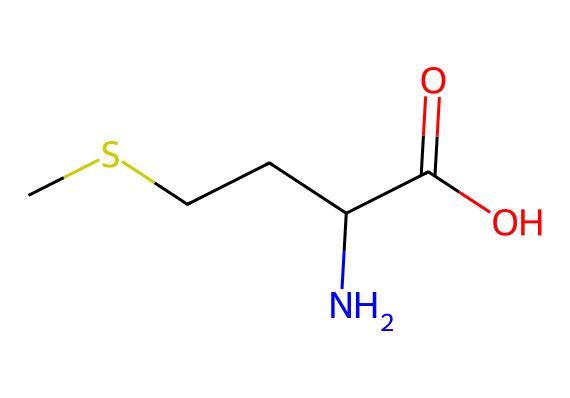What is the molecular formula of methionine? To determine the molecular formula, count the number of each type of atom present in the SMILES representation. The breakdown from CSCCC(N)C(=O)O shows there are 5 carbon (C) atoms, 11 hydrogen (H) atoms, 1 nitrogen (N) atom, and 2 oxygen (O) atoms, leading to the formula C5H11NO2.
Answer: C5H11NO2 How many chiral centers are in methionine? A chiral center is typically identified by examining the carbon atoms that have four different substituents attached. In methionine, the alpha carbon next to the carboxyl group is the only chiral center, so there is one chiral center in the molecule.
Answer: 1 What functional groups are present in methionine? The SMILES representation indicates functional groups: the carboxylic acid group (C(=O)O) and an amine group (C(N)). Identifying these characteristics helps classify methionine as an amino acid.
Answer: carboxylic acid and amine What type of amino acid is methionine? To determine the type of amino acid, we classify amino acids based on the properties of their side chains. Methionine contains a thioether in its side chain (the sulfur atom) and is classified as a nonpolar or hydrophobic amino acid.
Answer: nonpolar What role does methionine play in proteins? Methionine serves as the initiator of protein synthesis in eukaryotic cells as it encodes the start codon. This function is crucial in starting the translation process, which builds proteins in the cell.
Answer: initiator How many total atoms are present in methionine? By adding up all the atoms from the molecular formula C5H11NO2, we have 5 (C) + 11 (H) + 1 (N) + 2 (O) = 19 total atoms in methionine.
Answer: 19 What is the significance of sulfur in methionine? Sulfur is unique to organosulfur compounds and methionine being an organosulfur amino acid signifies it can participate in certain biochemical reactions, such as helping in methyl group transfers, which are important for various metabolic pathways.
Answer: methyl group transfers 